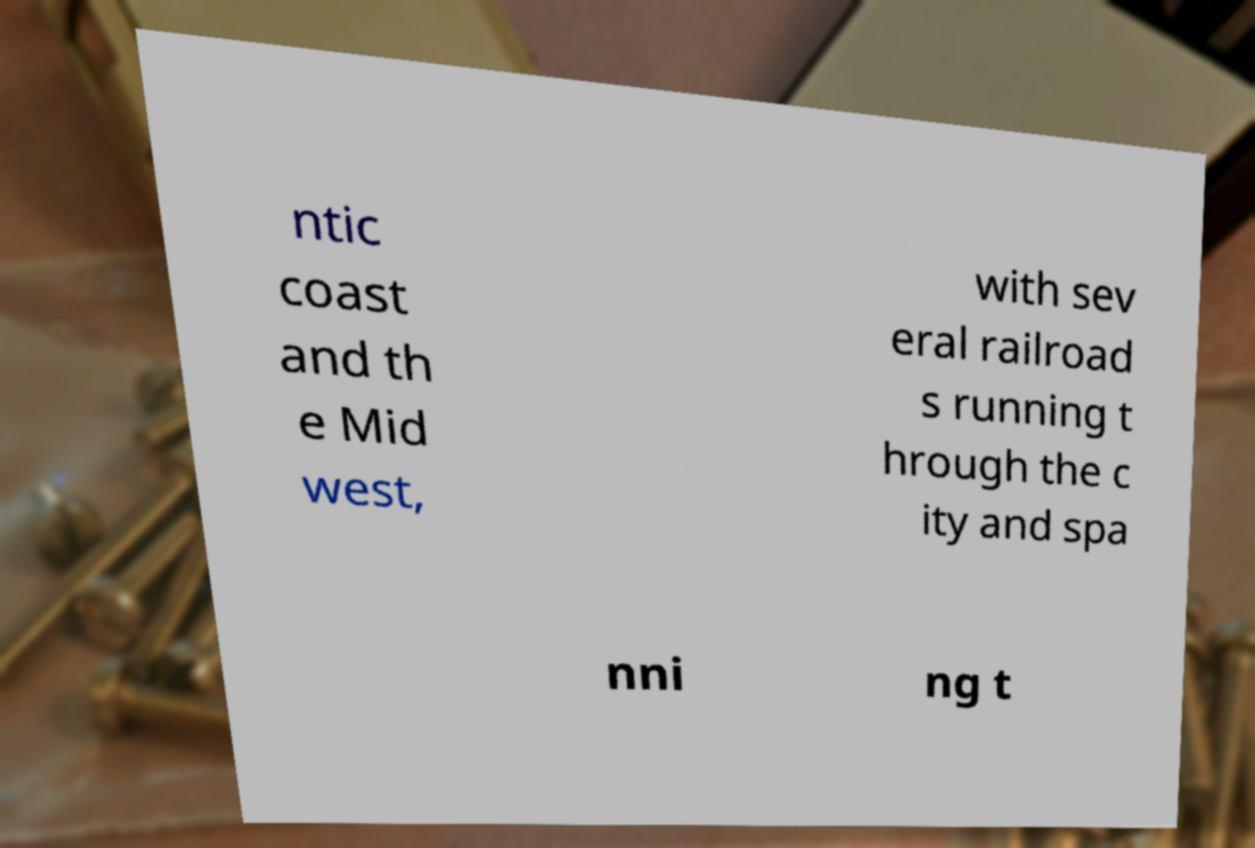Could you extract and type out the text from this image? ntic coast and th e Mid west, with sev eral railroad s running t hrough the c ity and spa nni ng t 